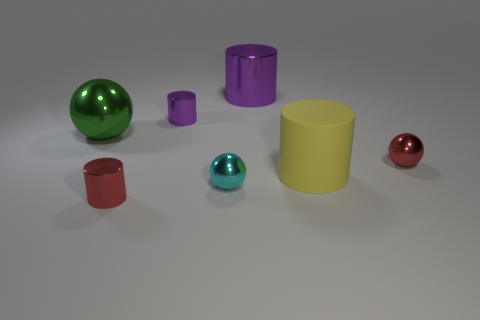Add 2 tiny red metal cylinders. How many objects exist? 9 Subtract all cylinders. How many objects are left? 3 Add 2 red shiny balls. How many red shiny balls are left? 3 Add 5 purple things. How many purple things exist? 7 Subtract 1 red balls. How many objects are left? 6 Subtract all blue rubber balls. Subtract all green metal objects. How many objects are left? 6 